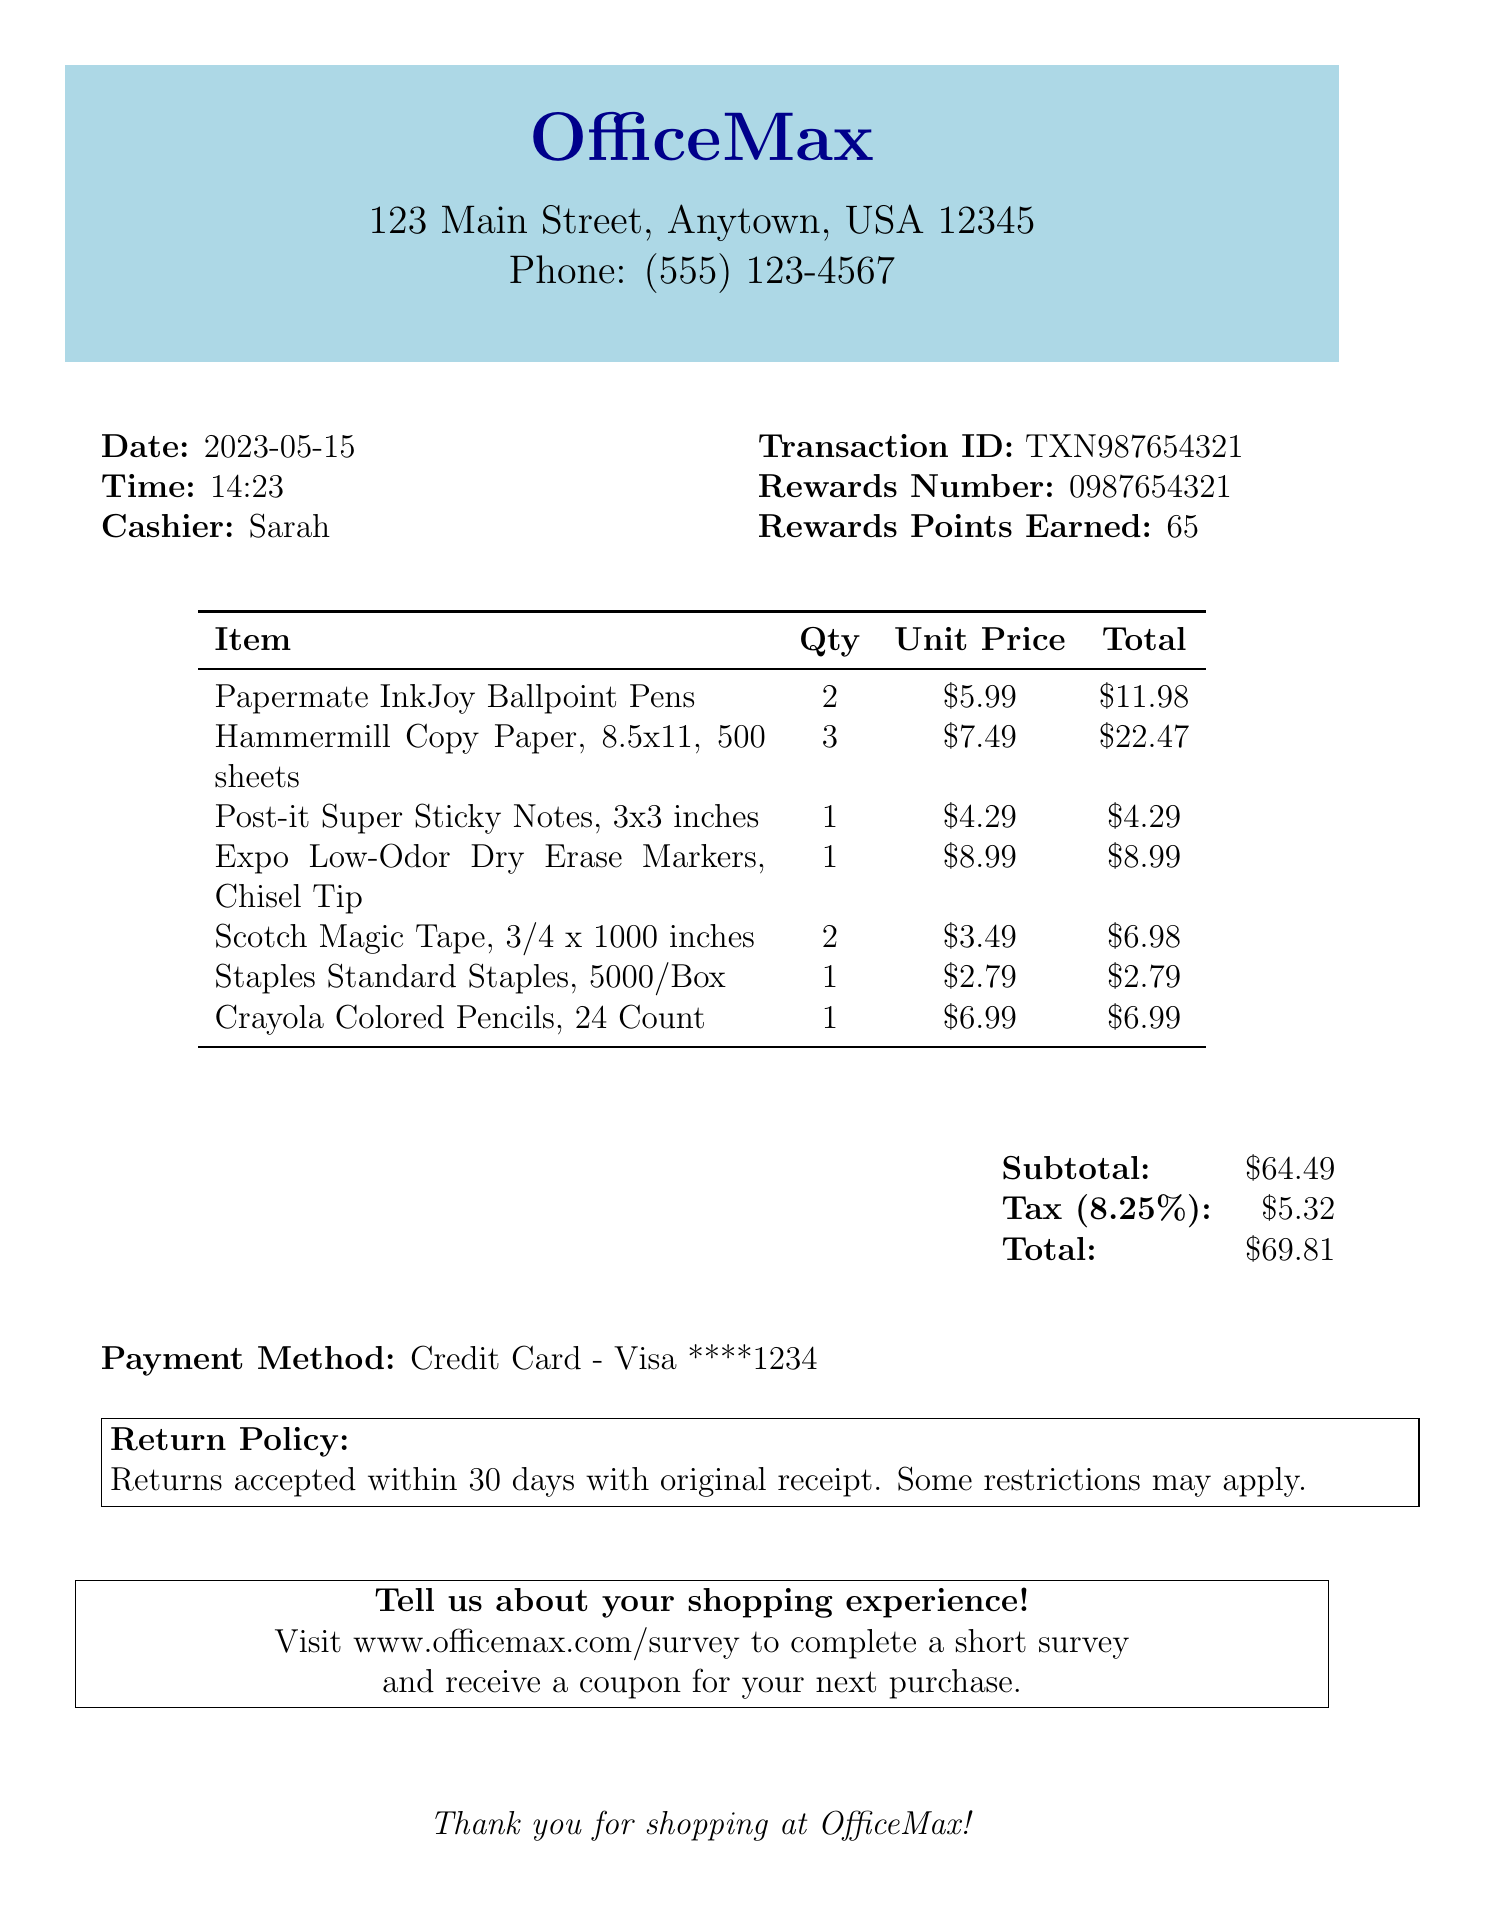What is the store name? The store name is listed at the top of the document, which is OfficeMax.
Answer: OfficeMax What is the date of the purchase? The date of the purchase is found under the date label in the document, which is May 15, 2023.
Answer: 2023-05-15 How many Hammermill Copy Paper packs were purchased? The quantity of Hammermill Copy Paper is specified in the item list, which indicates 3 packs were bought.
Answer: 3 What is the tax amount? The tax amount can be seen in the summary section of the receipt, which shows $5.32.
Answer: $5.32 Who was the cashier for this transaction? The cashier's name is mentioned in the document, which is Sarah.
Answer: Sarah What is the total amount after tax? The total amount after tax is provided in the summary section, which is $69.81.
Answer: $69.81 How many rewards points were earned from this purchase? The rewards points earned are indicated in the transaction details, which state 65 points were earned.
Answer: 65 What is the payment method used? The payment method is stated in the receipt as Credit Card - Visa.
Answer: Credit Card - Visa What is the return policy stated? The return policy is explained within a box on the receipt, stating returns are accepted within 30 days with the original receipt.
Answer: Returns accepted within 30 days with original receipt 